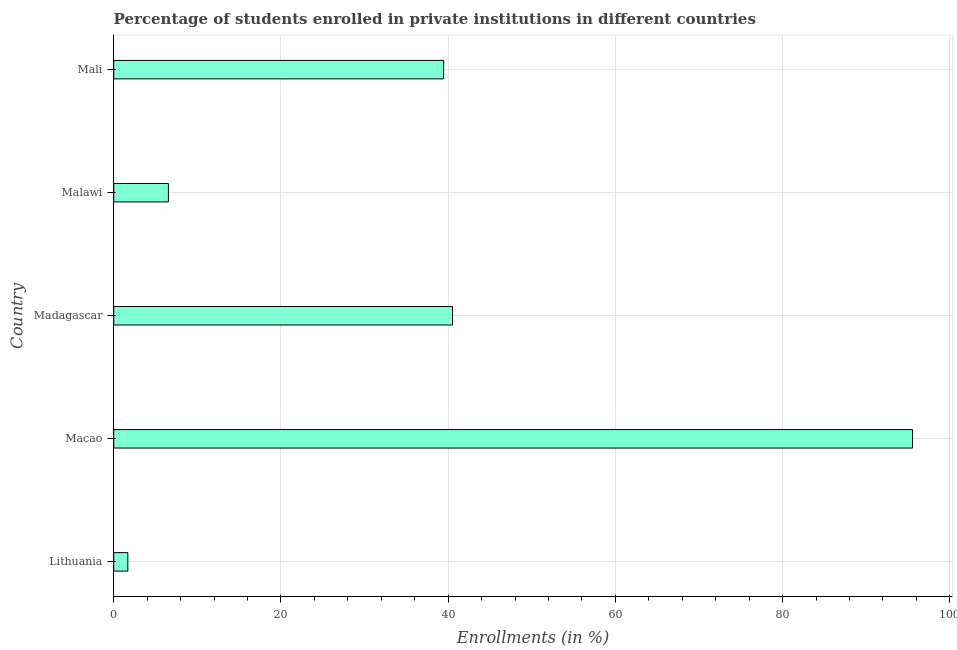Does the graph contain grids?
Provide a succinct answer. Yes. What is the title of the graph?
Offer a very short reply. Percentage of students enrolled in private institutions in different countries. What is the label or title of the X-axis?
Provide a succinct answer. Enrollments (in %). What is the label or title of the Y-axis?
Your answer should be compact. Country. What is the enrollments in private institutions in Malawi?
Ensure brevity in your answer.  6.54. Across all countries, what is the maximum enrollments in private institutions?
Your response must be concise. 95.54. Across all countries, what is the minimum enrollments in private institutions?
Offer a very short reply. 1.69. In which country was the enrollments in private institutions maximum?
Provide a short and direct response. Macao. In which country was the enrollments in private institutions minimum?
Keep it short and to the point. Lithuania. What is the sum of the enrollments in private institutions?
Provide a short and direct response. 183.75. What is the difference between the enrollments in private institutions in Madagascar and Mali?
Keep it short and to the point. 1.06. What is the average enrollments in private institutions per country?
Provide a succinct answer. 36.75. What is the median enrollments in private institutions?
Give a very brief answer. 39.46. In how many countries, is the enrollments in private institutions greater than 76 %?
Give a very brief answer. 1. What is the ratio of the enrollments in private institutions in Lithuania to that in Mali?
Offer a terse response. 0.04. Is the enrollments in private institutions in Lithuania less than that in Madagascar?
Your response must be concise. Yes. Is the difference between the enrollments in private institutions in Macao and Madagascar greater than the difference between any two countries?
Your answer should be compact. No. What is the difference between the highest and the second highest enrollments in private institutions?
Provide a succinct answer. 55.02. Is the sum of the enrollments in private institutions in Macao and Mali greater than the maximum enrollments in private institutions across all countries?
Your answer should be very brief. Yes. What is the difference between the highest and the lowest enrollments in private institutions?
Provide a short and direct response. 93.86. What is the difference between two consecutive major ticks on the X-axis?
Give a very brief answer. 20. What is the Enrollments (in %) in Lithuania?
Your answer should be compact. 1.69. What is the Enrollments (in %) of Macao?
Your answer should be compact. 95.54. What is the Enrollments (in %) of Madagascar?
Make the answer very short. 40.52. What is the Enrollments (in %) of Malawi?
Offer a terse response. 6.54. What is the Enrollments (in %) in Mali?
Offer a terse response. 39.46. What is the difference between the Enrollments (in %) in Lithuania and Macao?
Provide a short and direct response. -93.86. What is the difference between the Enrollments (in %) in Lithuania and Madagascar?
Your response must be concise. -38.84. What is the difference between the Enrollments (in %) in Lithuania and Malawi?
Provide a succinct answer. -4.85. What is the difference between the Enrollments (in %) in Lithuania and Mali?
Give a very brief answer. -37.77. What is the difference between the Enrollments (in %) in Macao and Madagascar?
Give a very brief answer. 55.02. What is the difference between the Enrollments (in %) in Macao and Malawi?
Your answer should be compact. 89. What is the difference between the Enrollments (in %) in Macao and Mali?
Keep it short and to the point. 56.09. What is the difference between the Enrollments (in %) in Madagascar and Malawi?
Offer a very short reply. 33.98. What is the difference between the Enrollments (in %) in Madagascar and Mali?
Ensure brevity in your answer.  1.06. What is the difference between the Enrollments (in %) in Malawi and Mali?
Offer a very short reply. -32.92. What is the ratio of the Enrollments (in %) in Lithuania to that in Macao?
Ensure brevity in your answer.  0.02. What is the ratio of the Enrollments (in %) in Lithuania to that in Madagascar?
Your answer should be very brief. 0.04. What is the ratio of the Enrollments (in %) in Lithuania to that in Malawi?
Keep it short and to the point. 0.26. What is the ratio of the Enrollments (in %) in Lithuania to that in Mali?
Ensure brevity in your answer.  0.04. What is the ratio of the Enrollments (in %) in Macao to that in Madagascar?
Provide a succinct answer. 2.36. What is the ratio of the Enrollments (in %) in Macao to that in Malawi?
Ensure brevity in your answer.  14.61. What is the ratio of the Enrollments (in %) in Macao to that in Mali?
Ensure brevity in your answer.  2.42. What is the ratio of the Enrollments (in %) in Madagascar to that in Malawi?
Your answer should be compact. 6.2. What is the ratio of the Enrollments (in %) in Malawi to that in Mali?
Your answer should be compact. 0.17. 